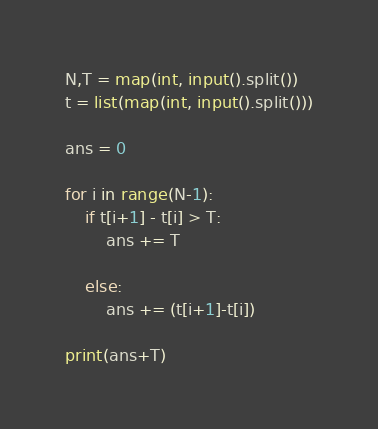<code> <loc_0><loc_0><loc_500><loc_500><_Python_>
N,T = map(int, input().split())
t = list(map(int, input().split()))

ans = 0

for i in range(N-1):
    if t[i+1] - t[i] > T:
        ans += T
        
    else:
        ans += (t[i+1]-t[i])
        
print(ans+T)</code> 